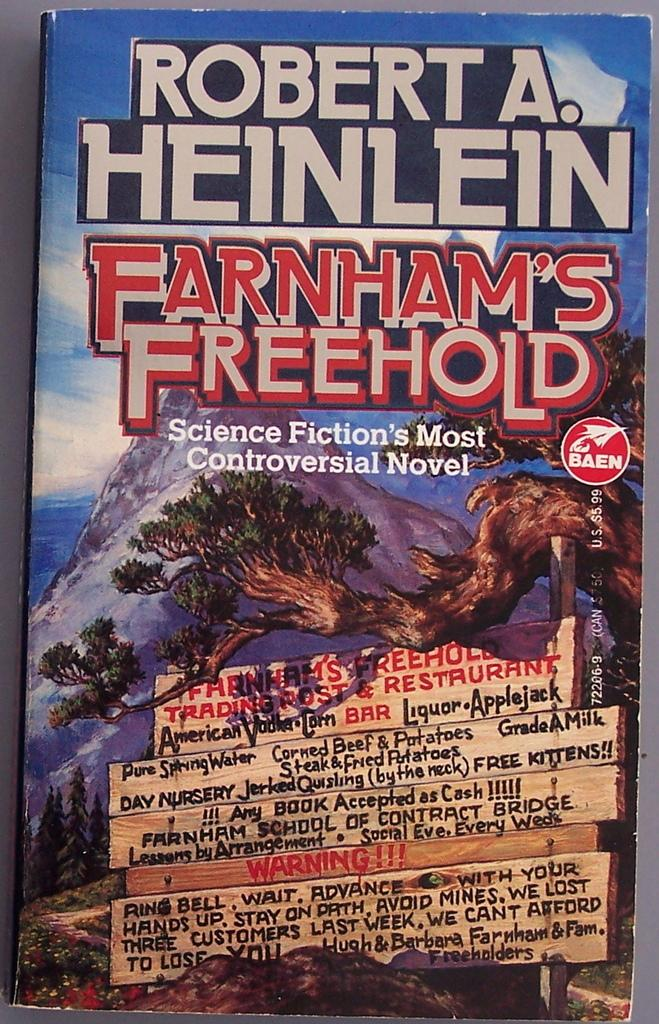Provide a one-sentence caption for the provided image. A science fiction book is titled Farnham's Freehold. 